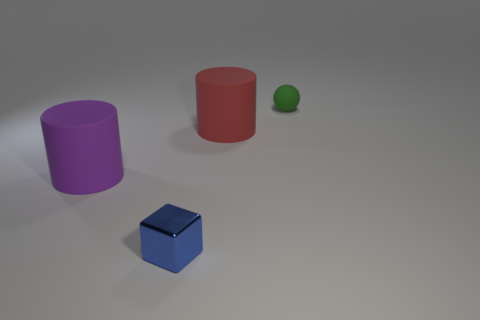Add 2 big purple objects. How many objects exist? 6 Subtract all cubes. How many objects are left? 3 Subtract all small cyan shiny objects. Subtract all small blue blocks. How many objects are left? 3 Add 1 rubber objects. How many rubber objects are left? 4 Add 1 tiny cyan matte things. How many tiny cyan matte things exist? 1 Subtract 0 yellow blocks. How many objects are left? 4 